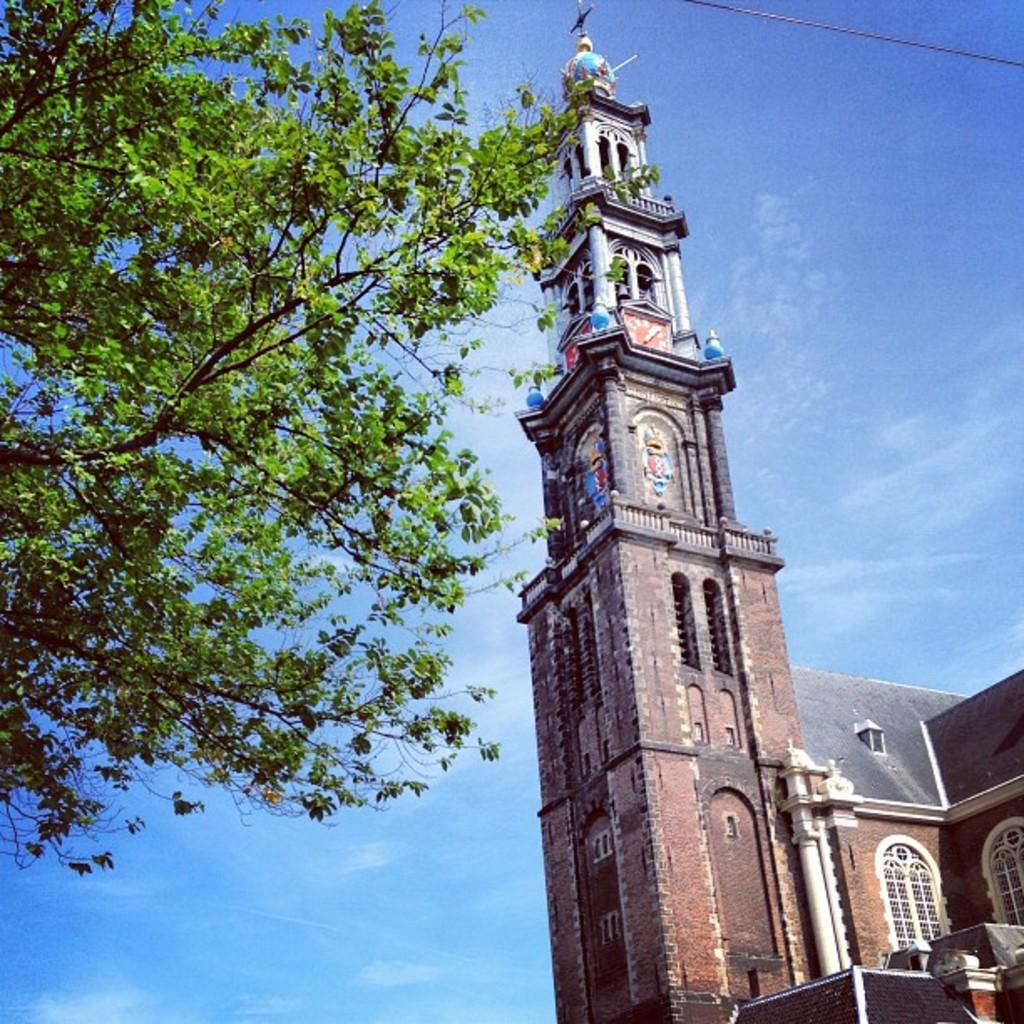What type of structure is present in the image? There is a building in the image. What can be seen on the left side of the image? There is a tree on the left side of the image. What is visible at the top of the image? The sky is visible at the top of the image. What color is the sky in the image? The sky is blue in the image. How does the impulse affect the scene in the image? There is no mention of an impulse in the image, so it cannot affect the scene. 